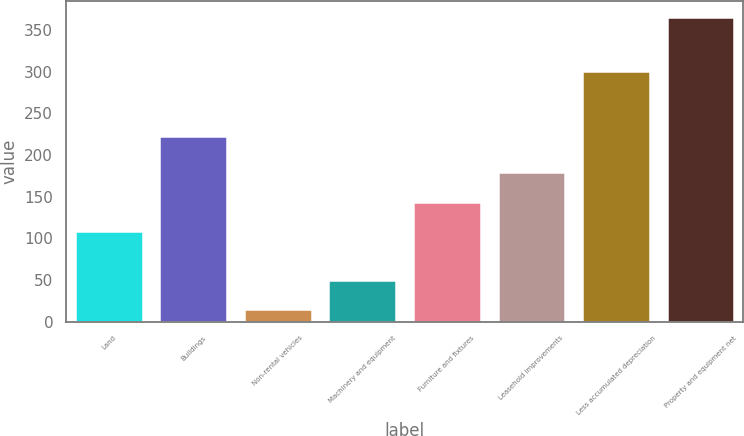<chart> <loc_0><loc_0><loc_500><loc_500><bar_chart><fcel>Land<fcel>Buildings<fcel>Non-rental vehicles<fcel>Machinery and equipment<fcel>Furniture and fixtures<fcel>Leasehold improvements<fcel>Less accumulated depreciation<fcel>Property and equipment net<nl><fcel>109<fcel>223<fcel>15<fcel>50.1<fcel>144.1<fcel>179.2<fcel>301<fcel>366<nl></chart> 